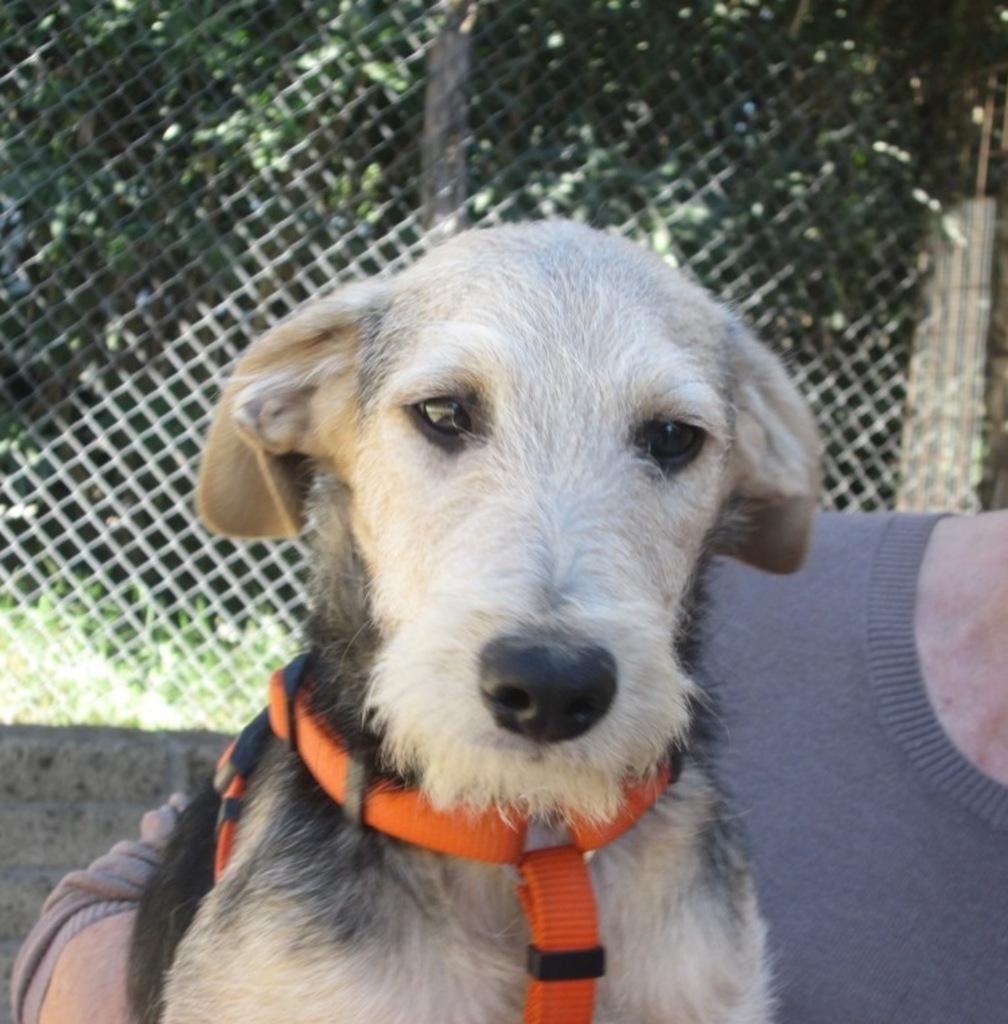What is the person in the image holding? The person is holding a dog in the image. What type of barrier is visible in the image? There is a metal fence visible in the image. What type of vegetation can be seen in the image? There are plants and trees in the image. What type of record is being played in the image? There is no record present in the image. What is the temper of the dog in the image? The image does not provide information about the dog's temperament. 